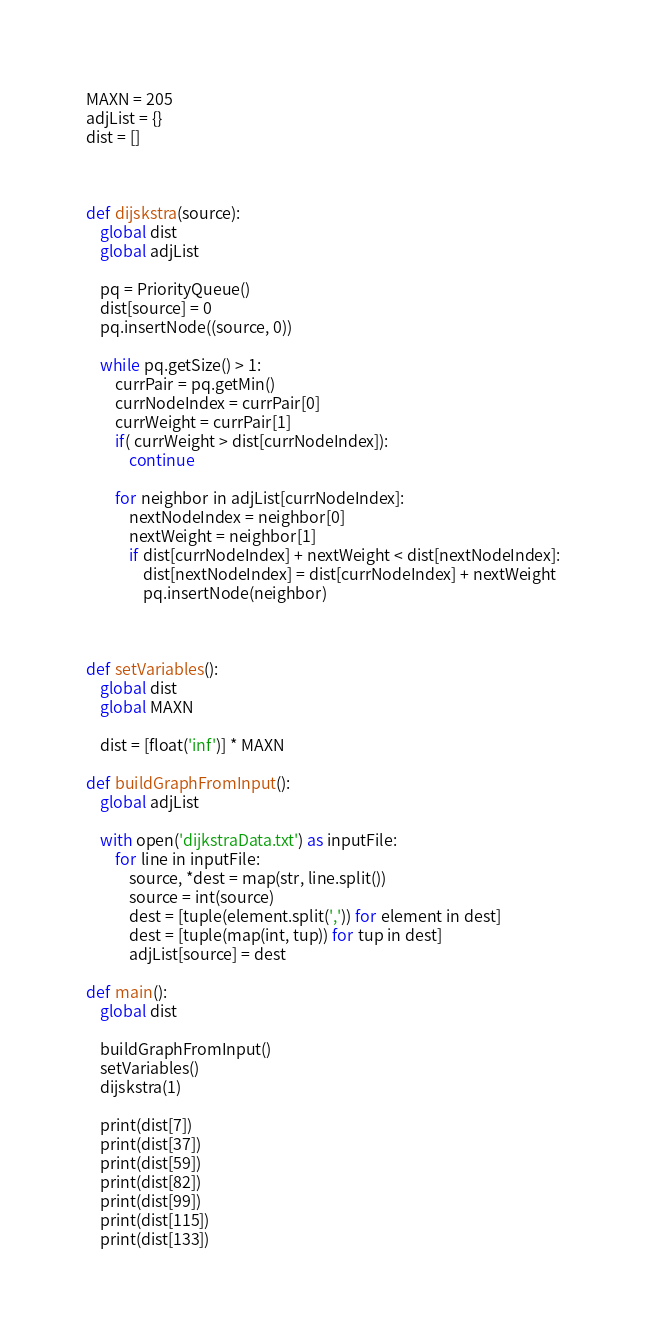Convert code to text. <code><loc_0><loc_0><loc_500><loc_500><_Python_>MAXN = 205
adjList = {}
dist = []



def dijskstra(source):
    global dist
    global adjList

    pq = PriorityQueue()
    dist[source] = 0
    pq.insertNode((source, 0))

    while pq.getSize() > 1:
        currPair = pq.getMin()
        currNodeIndex = currPair[0]
        currWeight = currPair[1]
        if( currWeight > dist[currNodeIndex]):
            continue
        
        for neighbor in adjList[currNodeIndex]:
            nextNodeIndex = neighbor[0]
            nextWeight = neighbor[1]
            if dist[currNodeIndex] + nextWeight < dist[nextNodeIndex]:
                dist[nextNodeIndex] = dist[currNodeIndex] + nextWeight
                pq.insertNode(neighbor)



def setVariables():
    global dist
    global MAXN

    dist = [float('inf')] * MAXN

def buildGraphFromInput():
    global adjList

    with open('dijkstraData.txt') as inputFile:
        for line in inputFile:
            source, *dest = map(str, line.split())
            source = int(source)
            dest = [tuple(element.split(',')) for element in dest]
            dest = [tuple(map(int, tup)) for tup in dest]
            adjList[source] = dest
            
def main():
    global dist

    buildGraphFromInput()
    setVariables()
    dijskstra(1)

    print(dist[7])
    print(dist[37])
    print(dist[59])
    print(dist[82])
    print(dist[99])
    print(dist[115])
    print(dist[133])</code> 